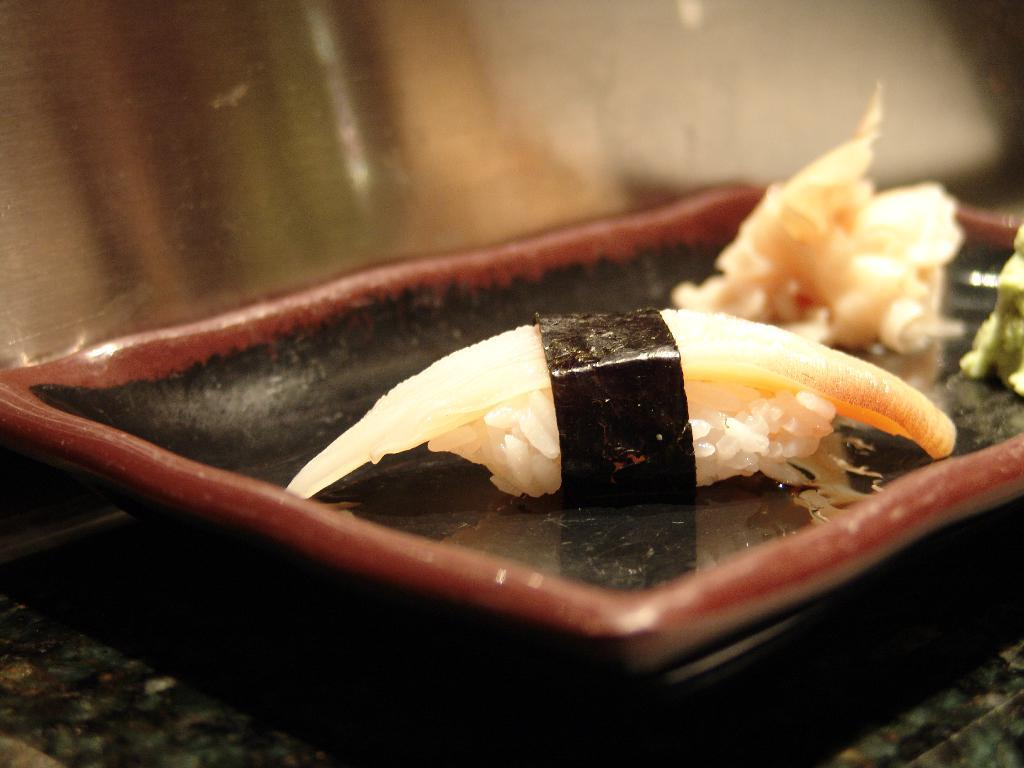What is on the table in the image? There is a plate on the table. What is on the plate? There is a significant amount of food on the plate. What type of joke is being told by the cabbage in the image? There is no cabbage present in the image, and therefore no joke being told. 